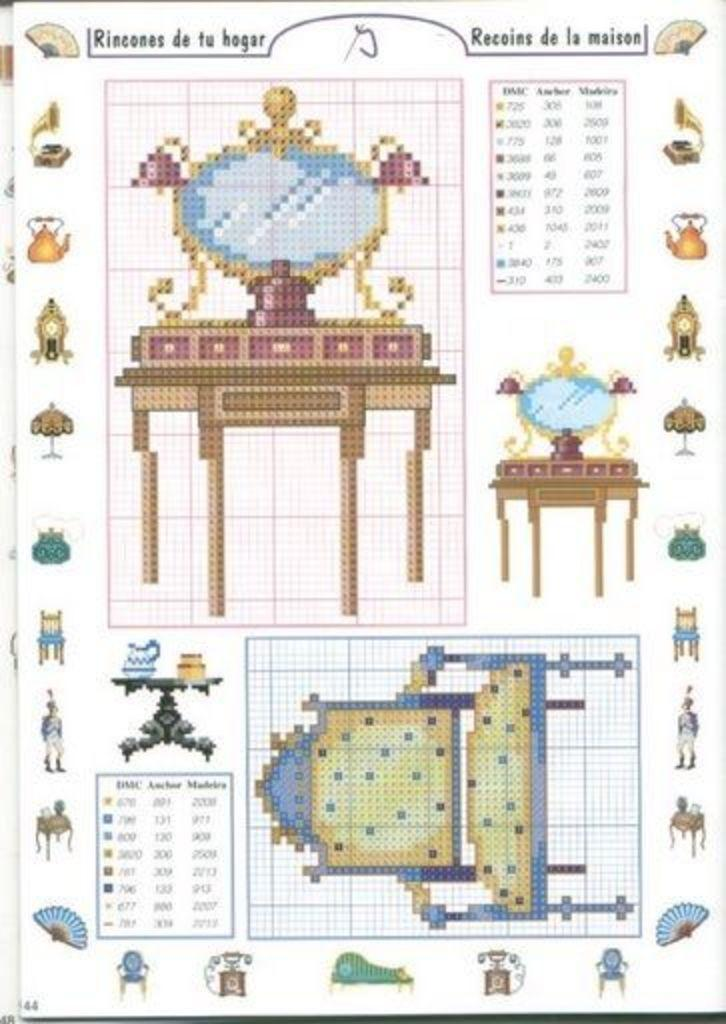What type of furniture is present in the image? There are chairs and tables in the image. What else can be seen on the chairs and tables? There are images and text visible on the chairs and tables. Can you see a drum being played in the image? There is no drum or any musical instrument being played in the image. Is there a whip visible in the image? There is no whip or any object related to whipping in the image. 